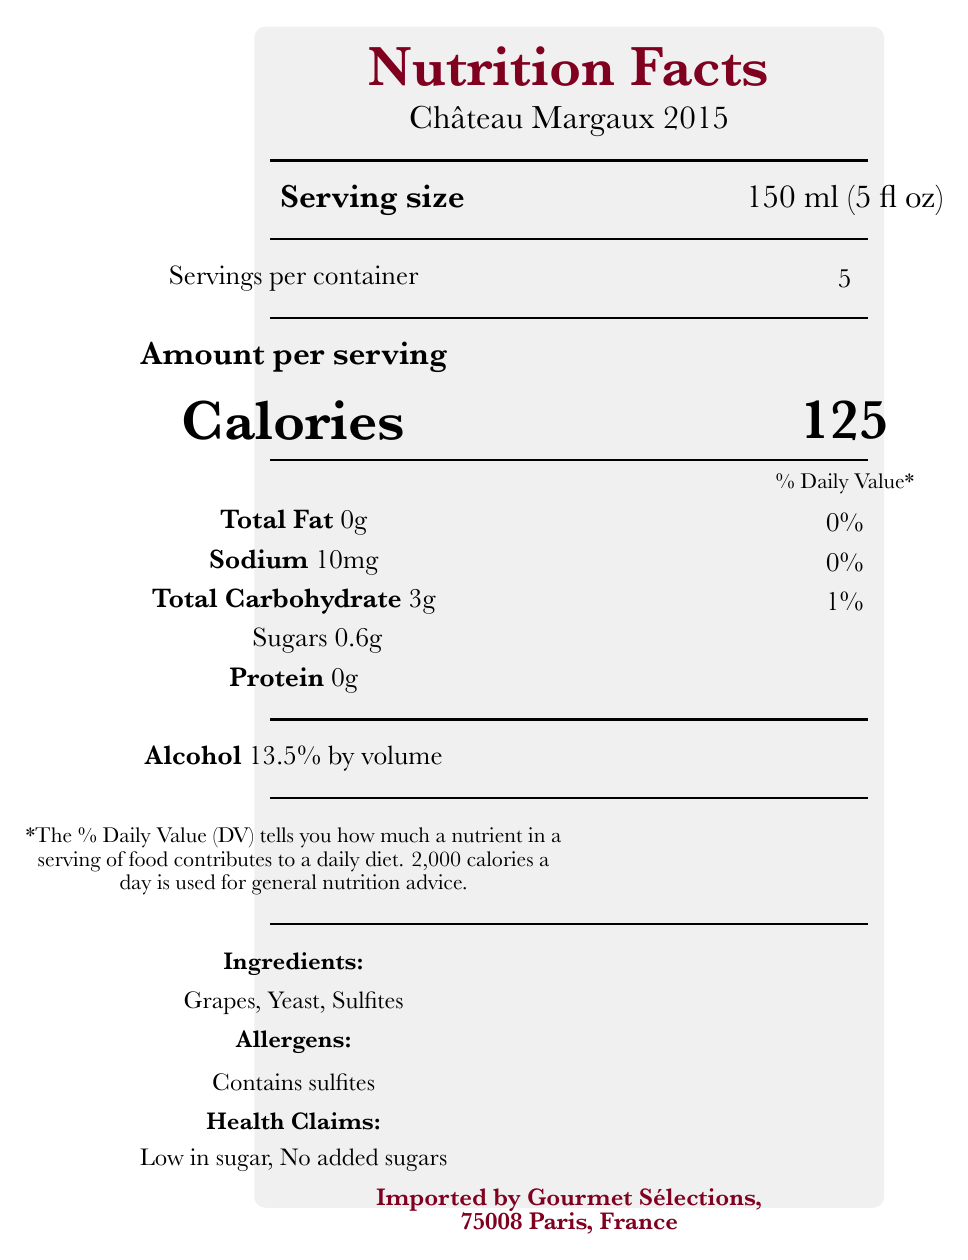What is the serving size of Château Margaux 2015? The document specifies that the serving size is 150 ml (5 fl oz), located prominently under "Serving size."
Answer: 150 ml (5 fl oz) How many servings are there per container of Château Margaux 2015? The document states that there are 5 servings per container, noted just below the serving size information.
Answer: 5 How many calories are there per serving of Château Margaux 2015? The document indicates that each serving contains 125 calories, highlighted under the "Amount per serving" section.
Answer: 125 What is the total amount of sugars per serving in Château Margaux 2015? The document lists the amount of sugars per serving as 0.6g under the "Total Carbohydrate" section.
Answer: 0.6g What is the alcohol percentage by volume of Château Margaux 2015? The document specifies the alcohol content at 13.5% by volume, found under the "Alcohol" section.
Answer: 13.5% Which of the following ingredients are included in Château Margaux 2015? A. Grapes B. Yeast C. Sulfites D. All of the above The document lists Grapes, Yeast, and Sulfites as the ingredients in Château Margaux 2015.
Answer: D. All of the above What is the sodium content per serving in Château Margaux 2015? A. 0g B. 5mg C. 10mg D. 15mg The sodium content per serving is stated as 10mg, mentioned in the nutrients list of the document.
Answer: C. 10mg True or False: Château Margaux 2015 contains no added sugars. The health claims section indicates that the product is low in sugar and contains no added sugars.
Answer: True Summarize the main nutritional facts of Château Margaux 2015. The summary covers the essential nutritional facts such as serving size, calories, sugar content, alcohol percentage, ingredients, and notable health claims.
Answer: Château Margaux 2015 has a serving size of 150 ml (5 fl oz) with 5 servings per container. It contains 125 calories per serving and has low sugar (0.6g) and alcohol at 13.5% by volume. It contains 0g of total fat, 10mg of sodium, 3g of total carbohydrate, and 0g of protein. Ingredients include grapes, yeast, and sulfites, with noted allergens being sulfites. What are the grape varieties used in producing Château Margaux 2015? This specific information about grape varieties is mentioned in the provided data but does not appear in the visual representation of the document.
Answer: Cannot be determined What is the percentage of Daily Value (%DV) for total fat in Château Margaux 2015? The document shows that the total fat content per serving is 0g, which corresponds to 0% of the Daily Value.
Answer: 0% 